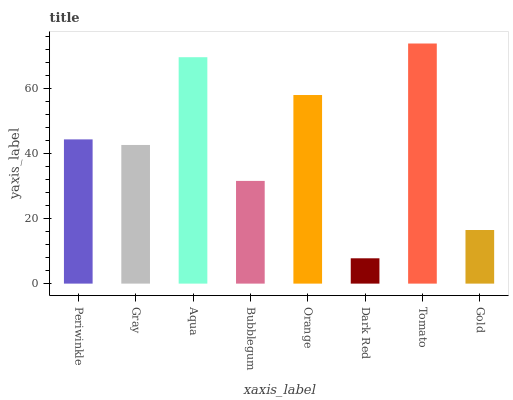Is Dark Red the minimum?
Answer yes or no. Yes. Is Tomato the maximum?
Answer yes or no. Yes. Is Gray the minimum?
Answer yes or no. No. Is Gray the maximum?
Answer yes or no. No. Is Periwinkle greater than Gray?
Answer yes or no. Yes. Is Gray less than Periwinkle?
Answer yes or no. Yes. Is Gray greater than Periwinkle?
Answer yes or no. No. Is Periwinkle less than Gray?
Answer yes or no. No. Is Periwinkle the high median?
Answer yes or no. Yes. Is Gray the low median?
Answer yes or no. Yes. Is Aqua the high median?
Answer yes or no. No. Is Gold the low median?
Answer yes or no. No. 